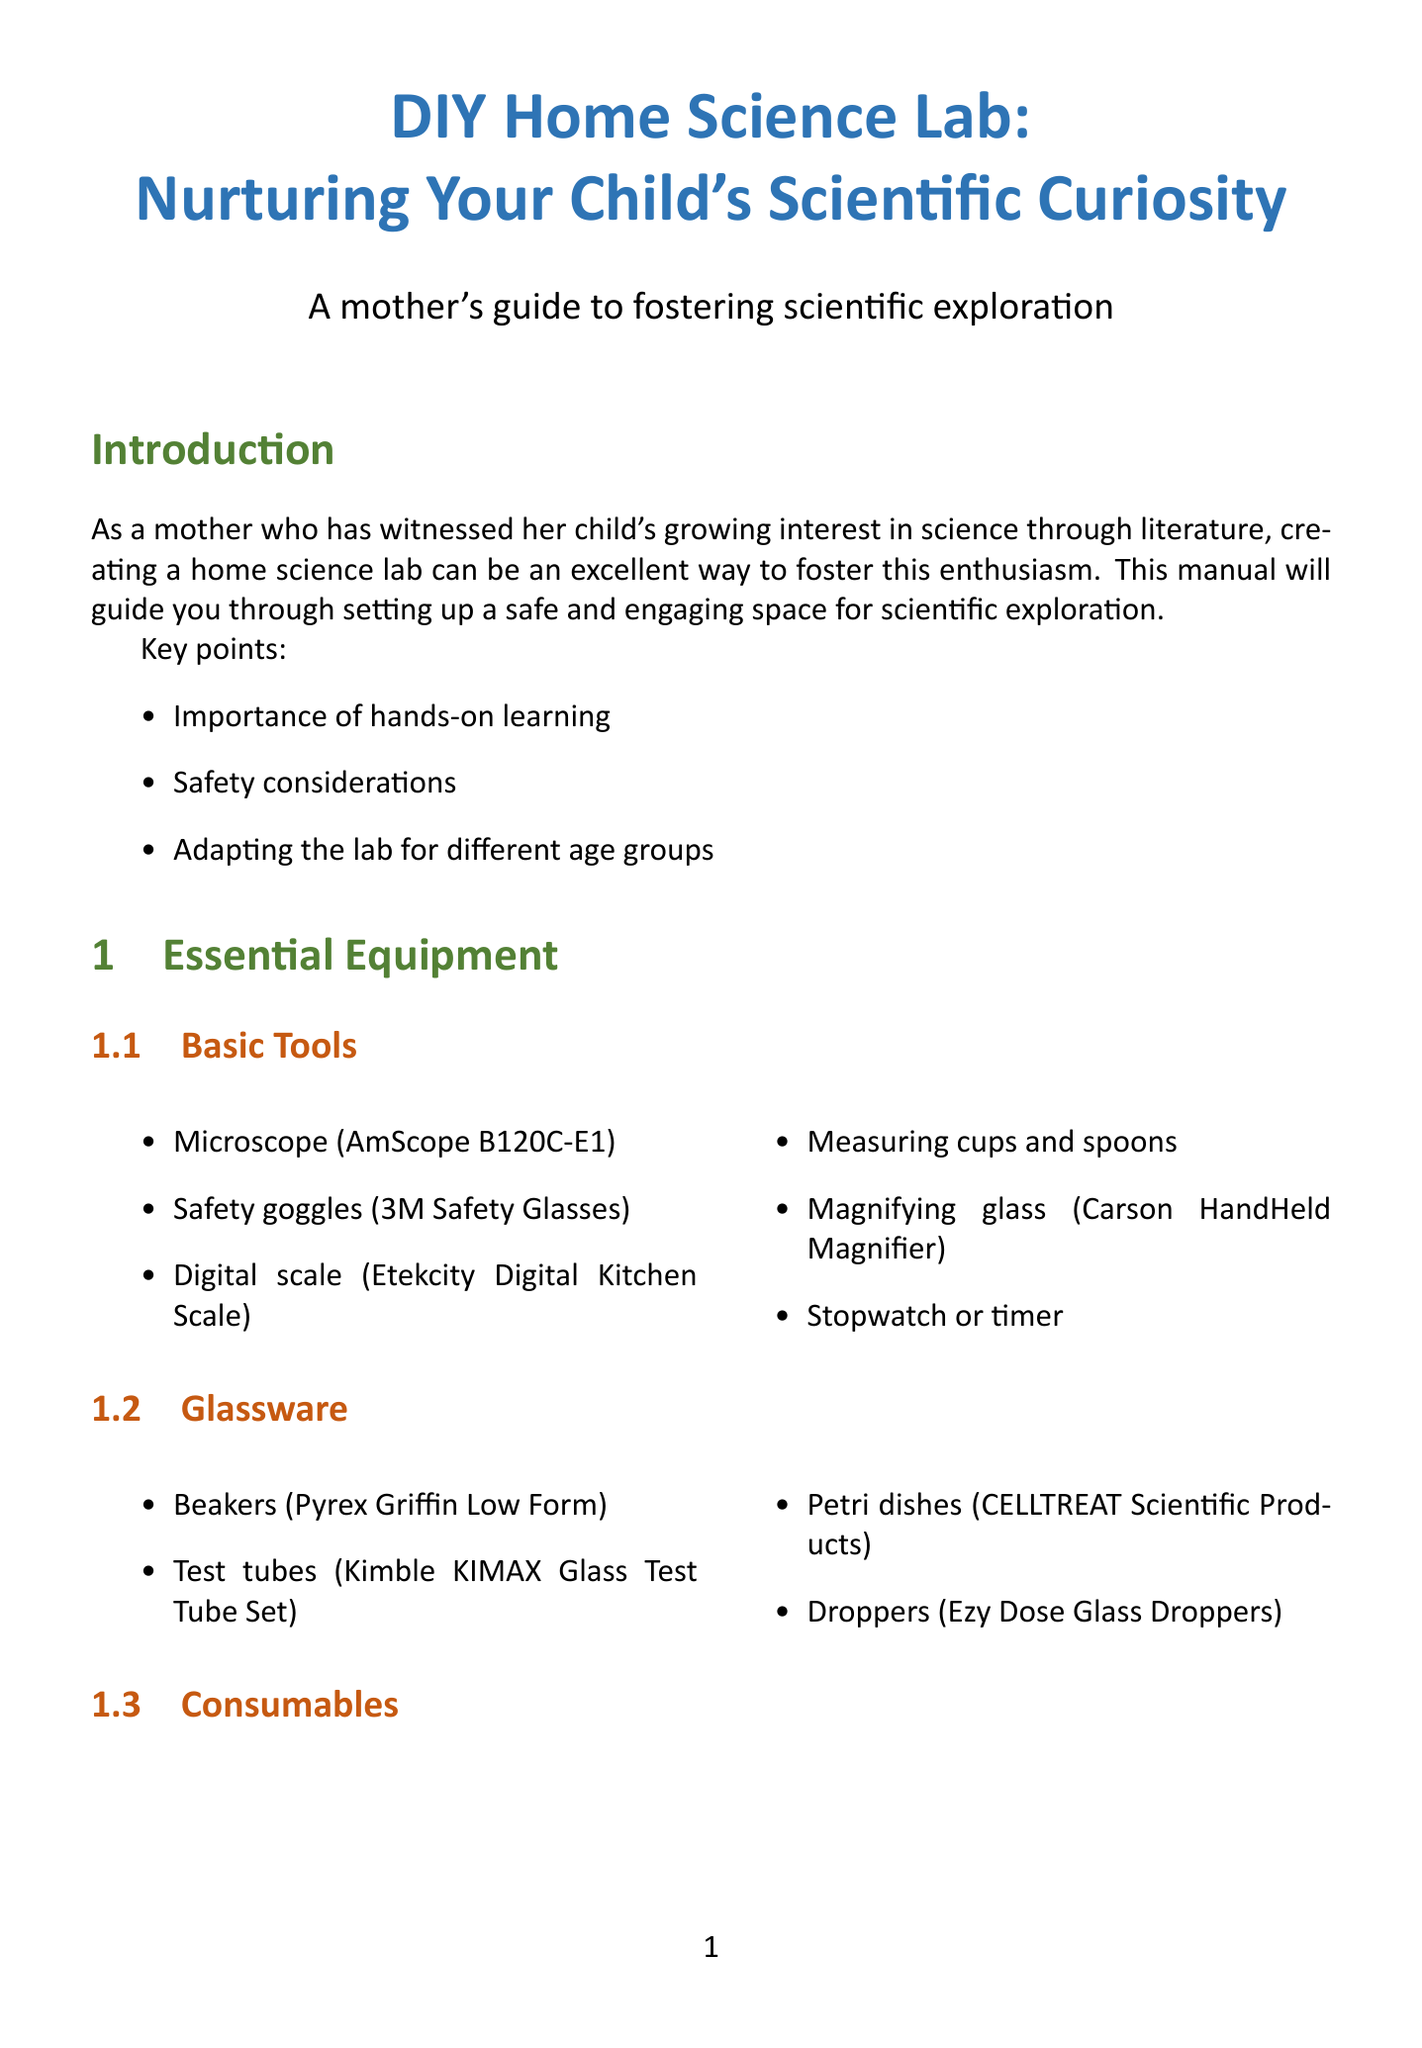what is the title of the manual? The title is stated at the top of the document and is aimed at nurturing scientific curiosity.
Answer: DIY Home Science Lab: Nurturing Your Child's Scientific Curiosity what is one basic tool listed in the essential equipment section? The essential equipment section includes a list of basic tools necessary for setting up a home science lab.
Answer: Microscope (AmScope B120C-E1) which shelving unit is recommended for storage solutions? The document provides recommendations for furniture and organizational tools for efficient storage solutions.
Answer: IKEA KALLAX how many safety considerations are included for the 5-8 years age group? The safety considerations for this age group are outlined under the adaptations section for different age groups.
Answer: Three name one recommended activity for ages 9-12. Recommended activities for this age group are mentioned under the specific adaptations for their learning.
Answer: Extracting DNA from fruit how often should glassware be inspected? The maintenance tips include daily, weekly, and monthly tasks for keeping the lab organized and safe.
Answer: Weekly which book is recommended for the age group of 9-12 years? The integrating literature section specifies book recommendations for children of various ages to complement their scientific learning.
Answer: The Way Things Work Now what is one daily maintenance tip? The maintenance section outlines specific daily, weekly, and monthly tips for lab upkeep and organization.
Answer: Clean work surfaces with disinfectant 